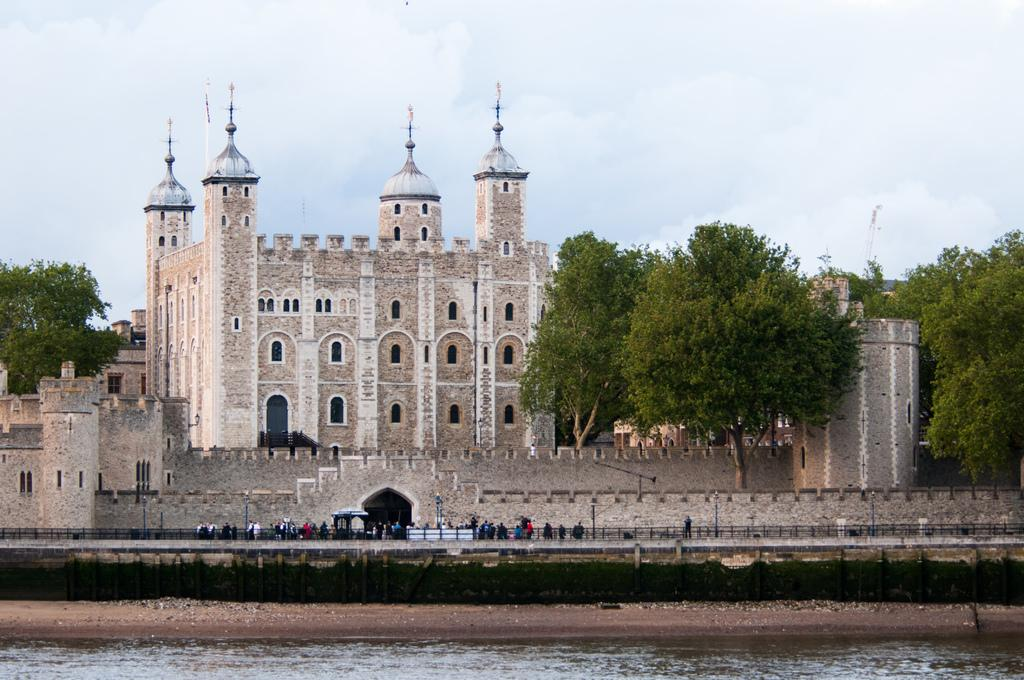What is visible at the bottom of the image? There is water visible at the bottom of the image. What can be seen in the background of the image? In the background of the image, there are poles, fencing, people, buildings, trees, clouds, and the sky. What type of canvas is being used by the person in the image? There is no person or canvas present in the image. What is the condition of the chin of the person in the image? There is no person present in the image, so it is not possible to determine the condition of their chin. 